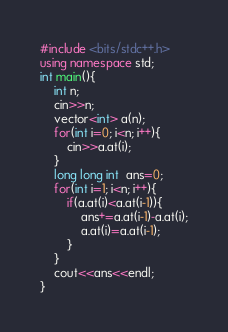Convert code to text. <code><loc_0><loc_0><loc_500><loc_500><_C++_>#include <bits/stdc++.h>
using namespace std;
int main(){
	int n;
	cin>>n;
	vector<int> a(n);
	for(int i=0; i<n; i++){
		cin>>a.at(i);
	}
	long long int  ans=0;
	for(int i=1; i<n; i++){
		if(a.at(i)<a.at(i-1)){
			ans+=a.at(i-1)-a.at(i);
			a.at(i)=a.at(i-1);
		}
	}
	cout<<ans<<endl;
}</code> 